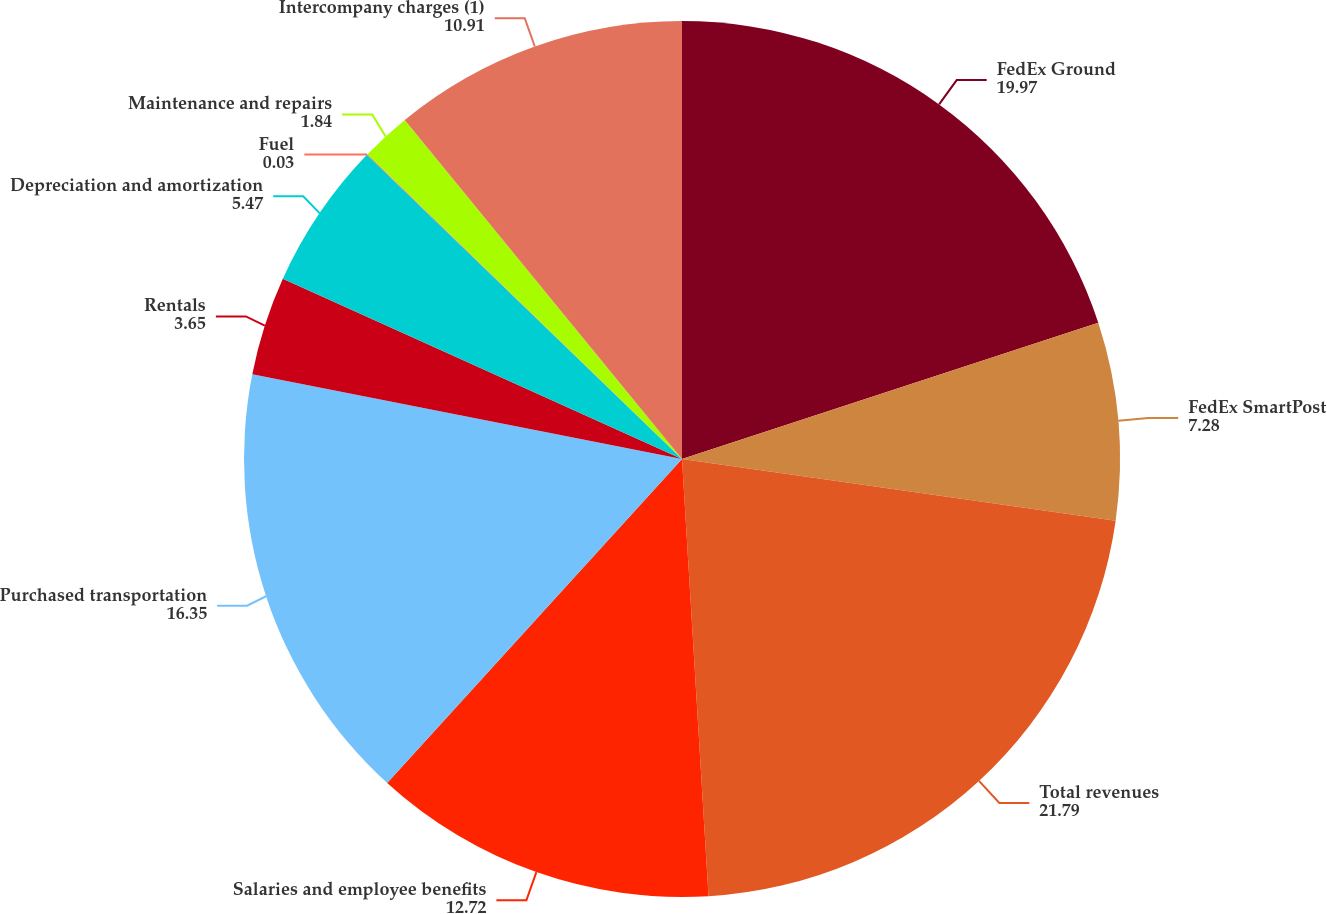<chart> <loc_0><loc_0><loc_500><loc_500><pie_chart><fcel>FedEx Ground<fcel>FedEx SmartPost<fcel>Total revenues<fcel>Salaries and employee benefits<fcel>Purchased transportation<fcel>Rentals<fcel>Depreciation and amortization<fcel>Fuel<fcel>Maintenance and repairs<fcel>Intercompany charges (1)<nl><fcel>19.97%<fcel>7.28%<fcel>21.79%<fcel>12.72%<fcel>16.35%<fcel>3.65%<fcel>5.47%<fcel>0.03%<fcel>1.84%<fcel>10.91%<nl></chart> 